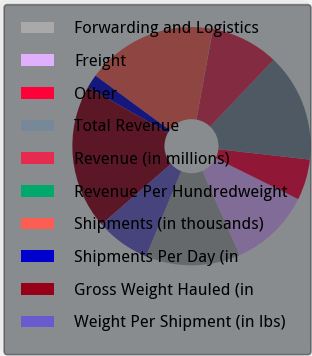Convert chart to OTSL. <chart><loc_0><loc_0><loc_500><loc_500><pie_chart><fcel>Forwarding and Logistics<fcel>Freight<fcel>Other<fcel>Total Revenue<fcel>Revenue (in millions)<fcel>Revenue Per Hundredweight<fcel>Shipments (in thousands)<fcel>Shipments Per Day (in<fcel>Gross Weight Hauled (in<fcel>Weight Per Shipment (in lbs)<nl><fcel>12.87%<fcel>11.04%<fcel>5.53%<fcel>14.7%<fcel>9.2%<fcel>0.03%<fcel>17.78%<fcel>1.87%<fcel>19.61%<fcel>7.37%<nl></chart> 